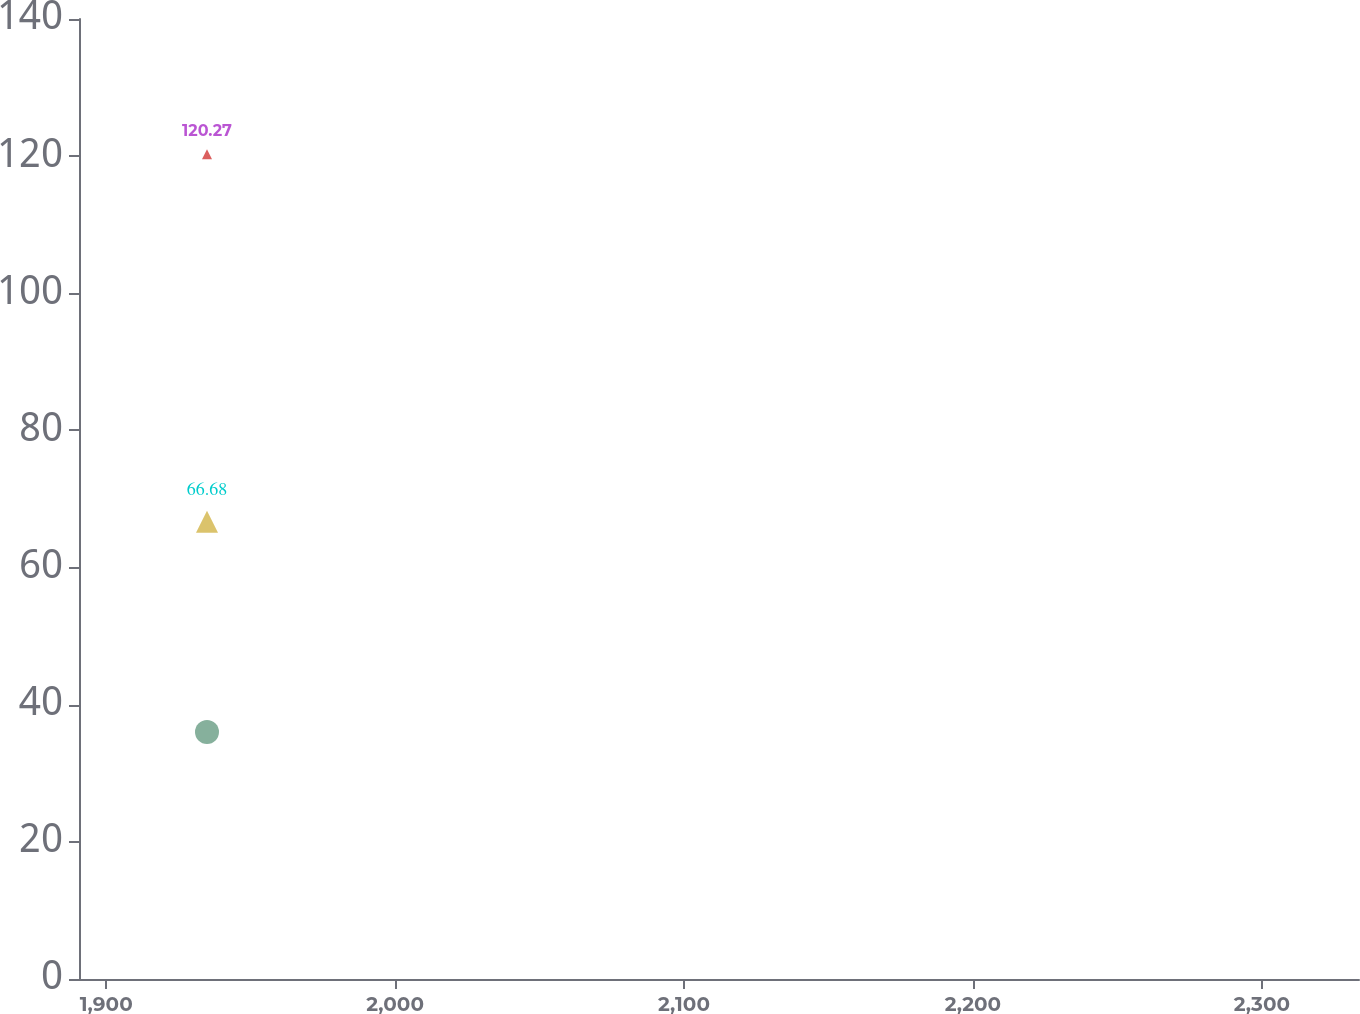Convert chart to OTSL. <chart><loc_0><loc_0><loc_500><loc_500><line_chart><ecel><fcel>Ameren Illinois<fcel>Ameren Missouri<fcel>Ameren (a)<nl><fcel>1934.87<fcel>120.27<fcel>66.68<fcel>36.01<nl><fcel>2335.29<fcel>127.92<fcel>64.4<fcel>18.5<nl><fcel>2377.92<fcel>72.37<fcel>42.41<fcel>16.55<nl></chart> 